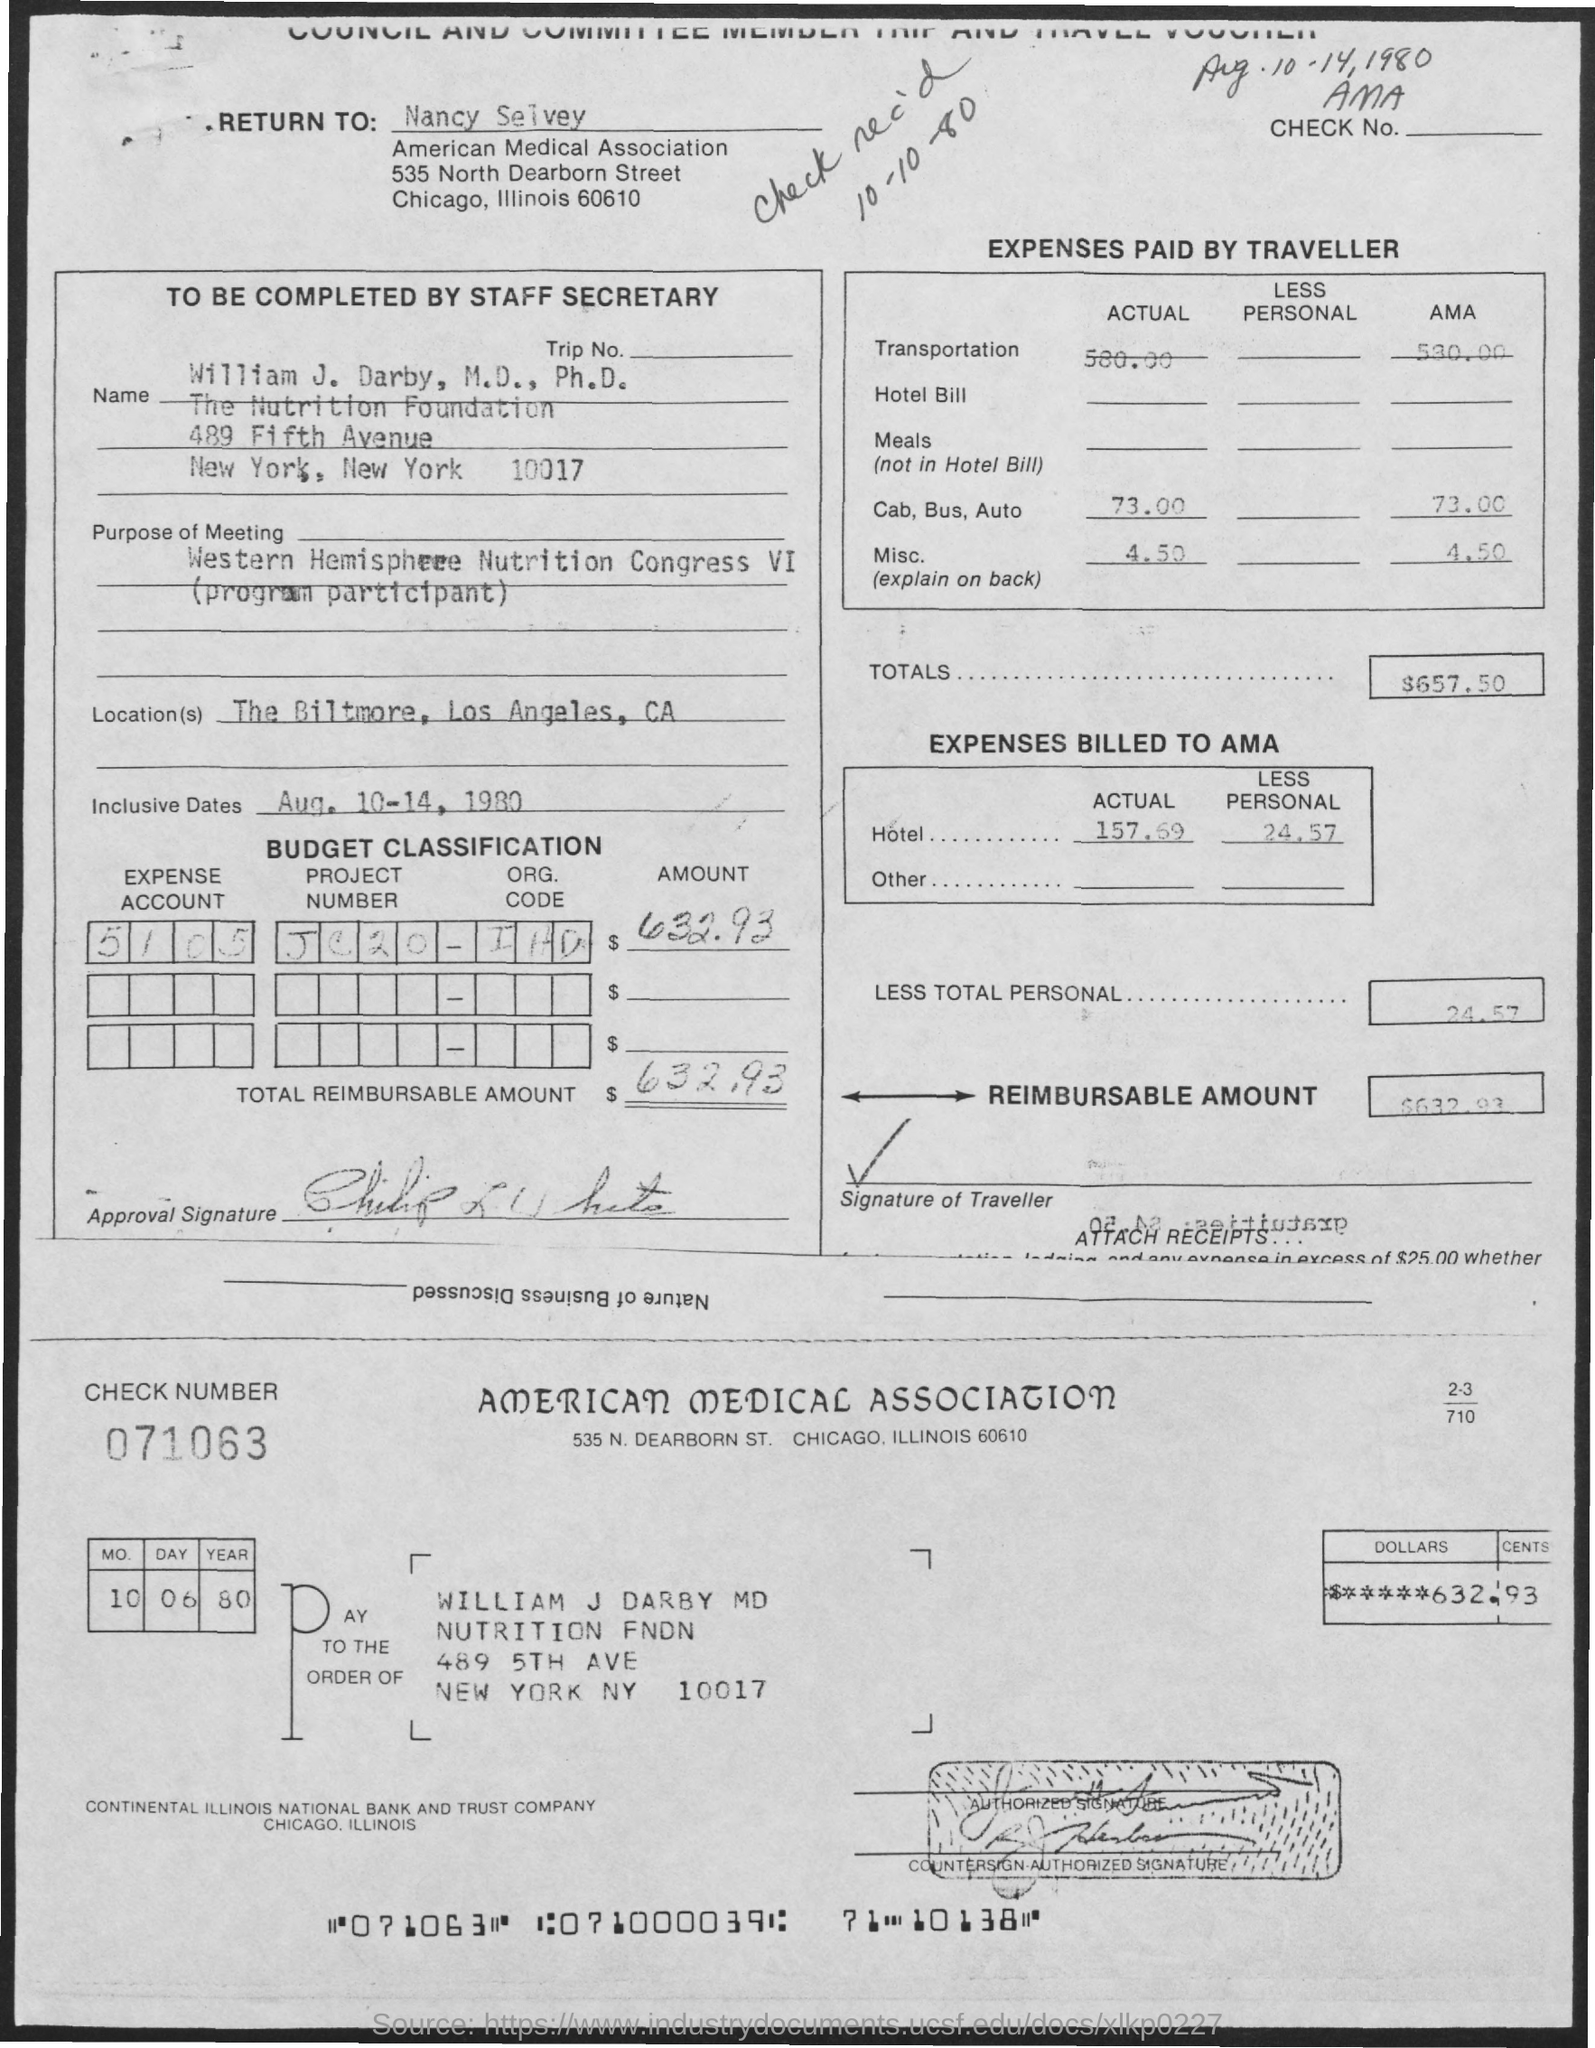What is the Check Number?
Provide a succinct answer. 071063. What is the Total?
Give a very brief answer. $657.50. What is the Project Number?
Offer a terse response. Jc20. What is the Expense Account?
Give a very brief answer. 5105. What is the Reimbursable Amount?
Provide a succinct answer. $632.93. 